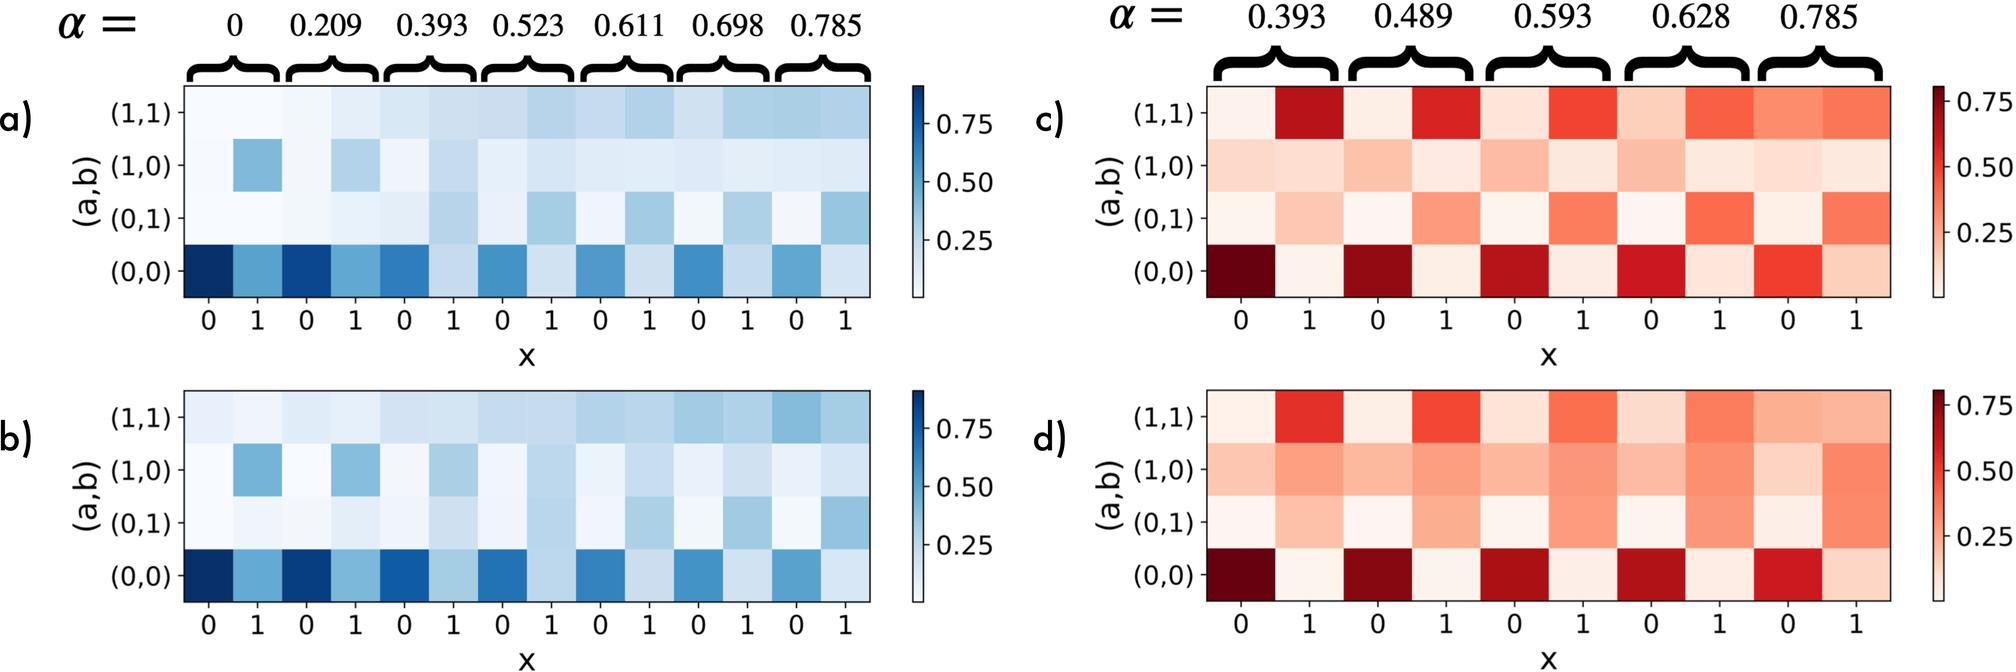How does the value of 'x' impact the observed correlations in figures a and b? The value of 'x' along the horizontal axis of the heatmaps appears to represent different experimental or sampling conditions under which the data was collected or simulated. As 'x' changes, it influences the correlation values observed in the grids of figures a and b. Changes in 'x' might alter the underlying dynamics or interactions between the studied variables, thus affecting the correlation coefficient. Analyzing how these values shift with changes in 'x' can provide insights into stability or variability of the relationship under different conditions. 